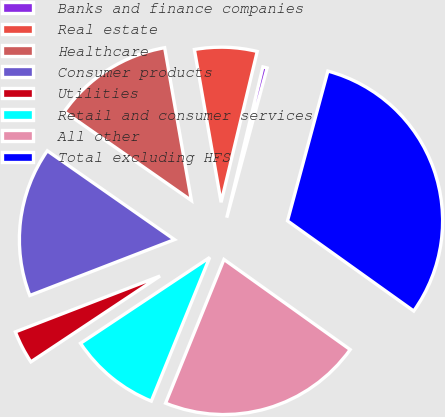<chart> <loc_0><loc_0><loc_500><loc_500><pie_chart><fcel>Banks and finance companies<fcel>Real estate<fcel>Healthcare<fcel>Consumer products<fcel>Utilities<fcel>Retail and consumer services<fcel>All other<fcel>Total excluding HFS<nl><fcel>0.45%<fcel>6.5%<fcel>12.54%<fcel>15.57%<fcel>3.47%<fcel>9.52%<fcel>21.27%<fcel>30.68%<nl></chart> 